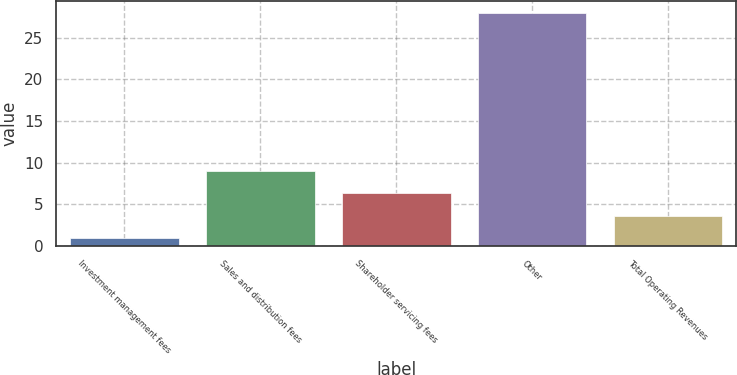Convert chart to OTSL. <chart><loc_0><loc_0><loc_500><loc_500><bar_chart><fcel>Investment management fees<fcel>Sales and distribution fees<fcel>Shareholder servicing fees<fcel>Other<fcel>Total Operating Revenues<nl><fcel>0.87<fcel>9<fcel>6.29<fcel>28<fcel>3.58<nl></chart> 